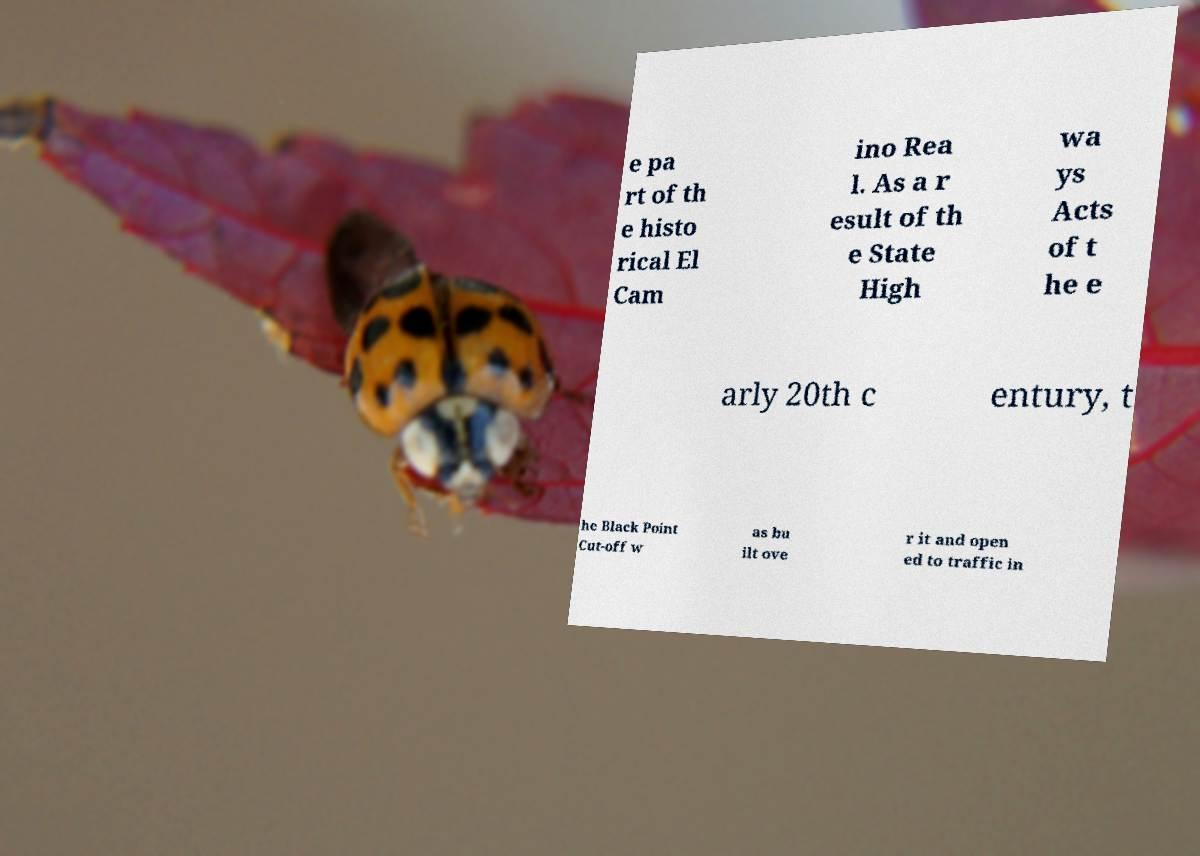Please identify and transcribe the text found in this image. e pa rt of th e histo rical El Cam ino Rea l. As a r esult of th e State High wa ys Acts of t he e arly 20th c entury, t he Black Point Cut-off w as bu ilt ove r it and open ed to traffic in 